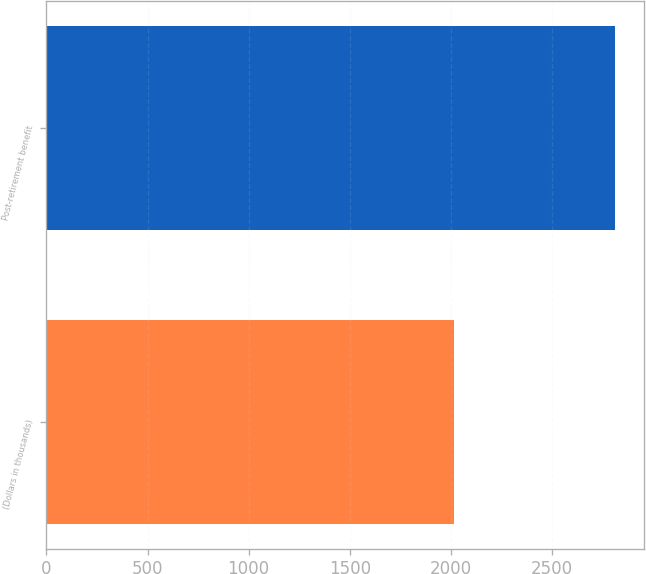Convert chart. <chart><loc_0><loc_0><loc_500><loc_500><bar_chart><fcel>(Dollars in thousands)<fcel>Post-retirement benefit<nl><fcel>2017<fcel>2814<nl></chart> 